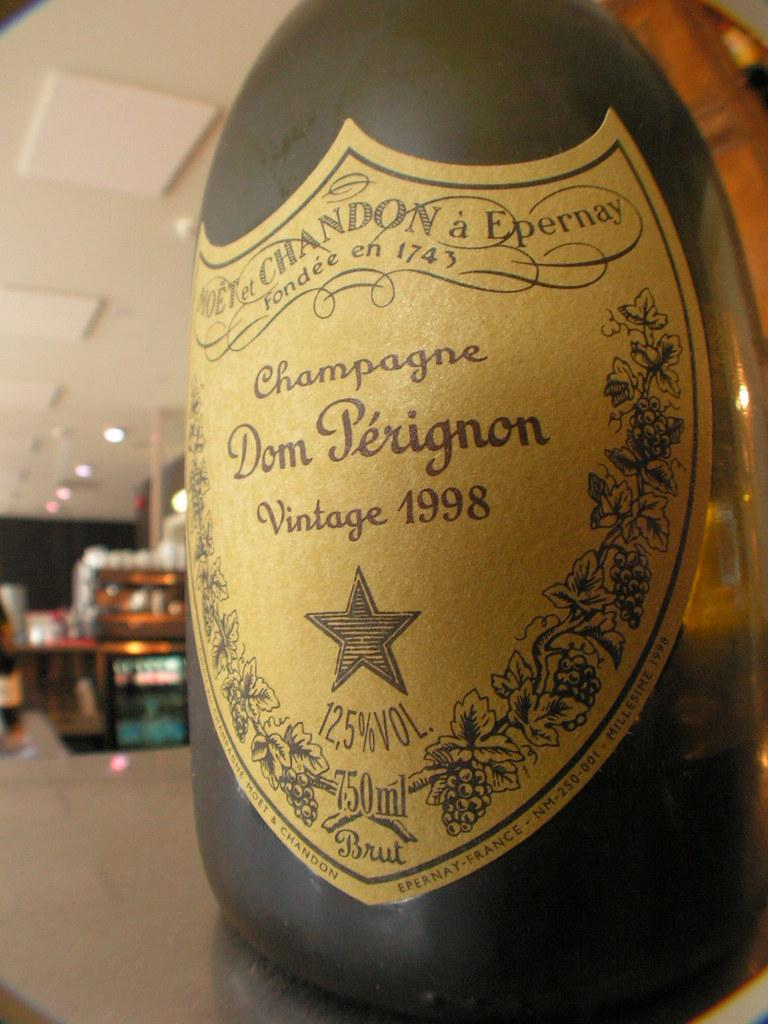<image>
Offer a succinct explanation of the picture presented. A 1998 bottle of Dom Perignon Champagne atop of a counter. 